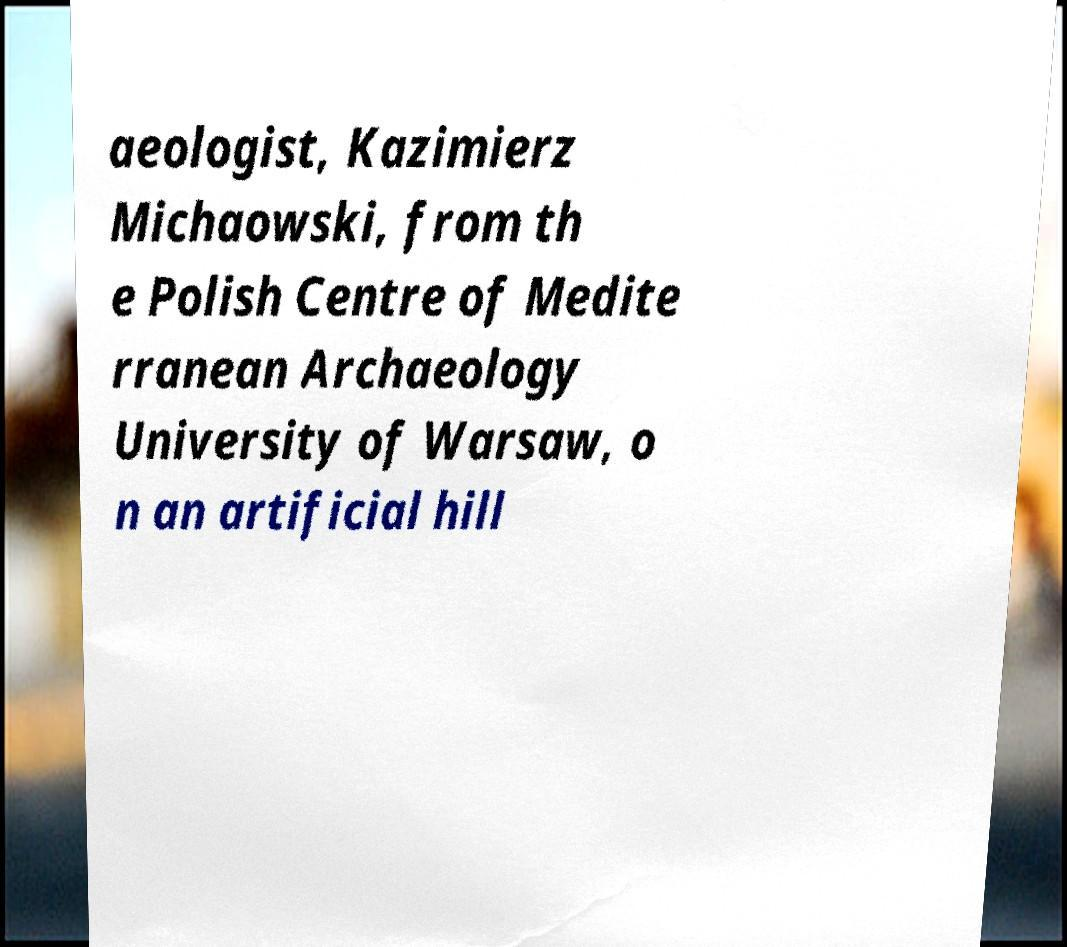Can you accurately transcribe the text from the provided image for me? aeologist, Kazimierz Michaowski, from th e Polish Centre of Medite rranean Archaeology University of Warsaw, o n an artificial hill 